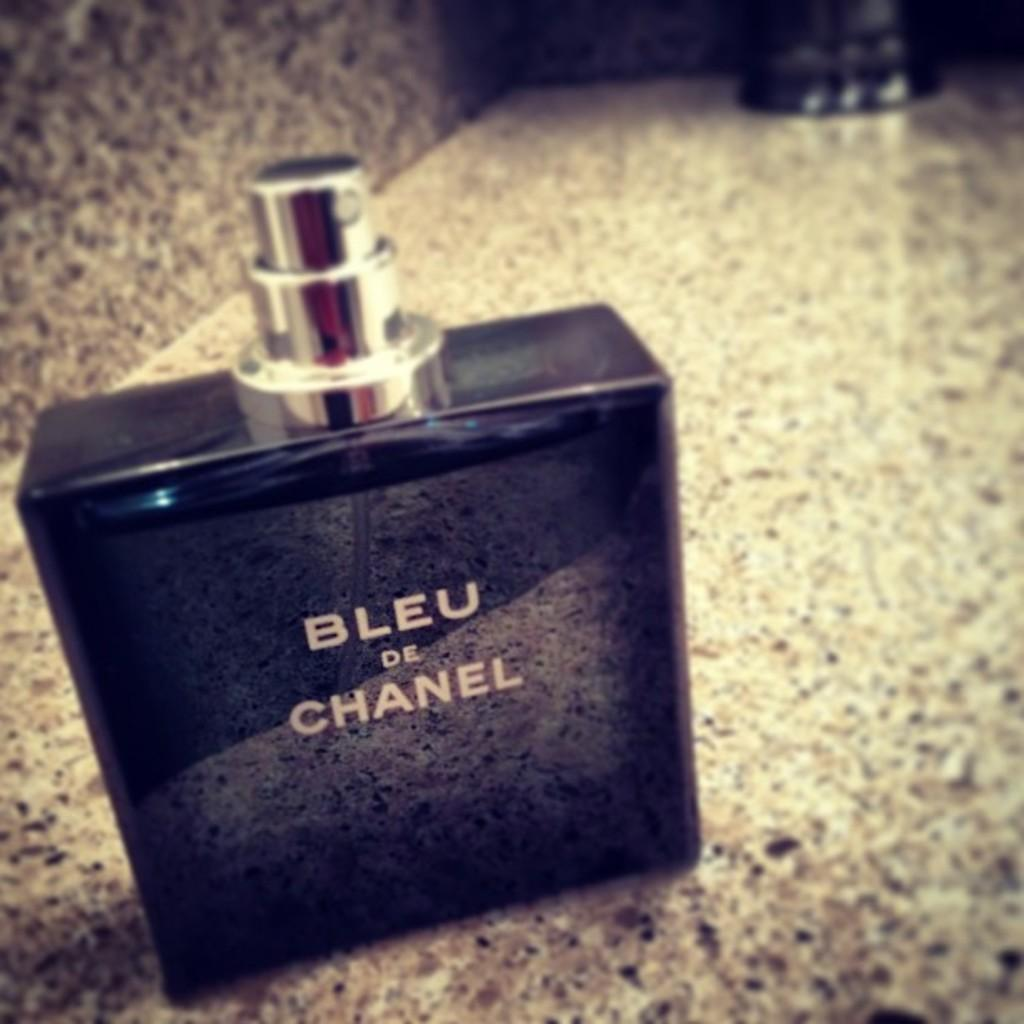Provide a one-sentence caption for the provided image. A bottle of Bleu de Chanel on a counter. 